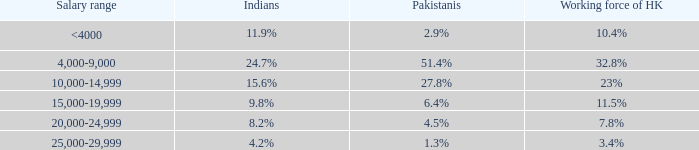Write the full table. {'header': ['Salary range', 'Indians', 'Pakistanis', 'Working force of HK'], 'rows': [['<4000', '11.9%', '2.9%', '10.4%'], ['4,000-9,000', '24.7%', '51.4%', '32.8%'], ['10,000-14,999', '15.6%', '27.8%', '23%'], ['15,000-19,999', '9.8%', '6.4%', '11.5%'], ['20,000-24,999', '8.2%', '4.5%', '7.8%'], ['25,000-29,999', '4.2%', '1.3%', '3.4%']]} For the 10.4% working population in hk, what are the income brackets? <4000. 